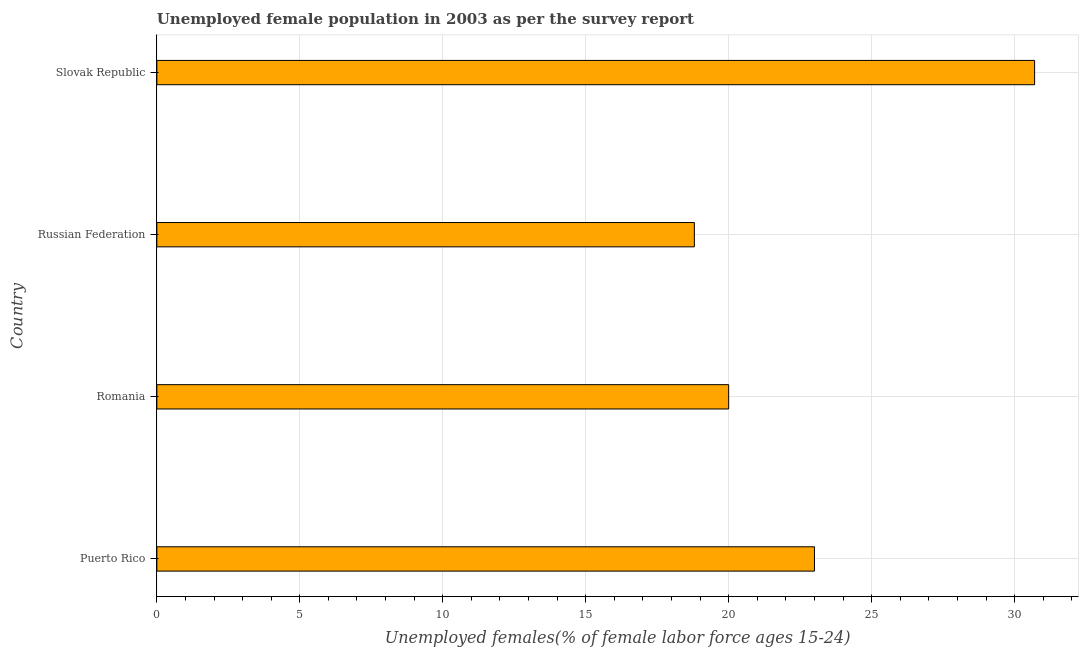Does the graph contain grids?
Your response must be concise. Yes. What is the title of the graph?
Provide a succinct answer. Unemployed female population in 2003 as per the survey report. What is the label or title of the X-axis?
Your answer should be very brief. Unemployed females(% of female labor force ages 15-24). What is the label or title of the Y-axis?
Offer a very short reply. Country. What is the unemployed female youth in Puerto Rico?
Keep it short and to the point. 23. Across all countries, what is the maximum unemployed female youth?
Keep it short and to the point. 30.7. Across all countries, what is the minimum unemployed female youth?
Give a very brief answer. 18.8. In which country was the unemployed female youth maximum?
Offer a terse response. Slovak Republic. In which country was the unemployed female youth minimum?
Ensure brevity in your answer.  Russian Federation. What is the sum of the unemployed female youth?
Provide a succinct answer. 92.5. What is the difference between the unemployed female youth in Romania and Slovak Republic?
Keep it short and to the point. -10.7. What is the average unemployed female youth per country?
Offer a very short reply. 23.12. What is the median unemployed female youth?
Ensure brevity in your answer.  21.5. In how many countries, is the unemployed female youth greater than 23 %?
Make the answer very short. 1. What is the ratio of the unemployed female youth in Puerto Rico to that in Romania?
Provide a short and direct response. 1.15. Is the difference between the unemployed female youth in Puerto Rico and Russian Federation greater than the difference between any two countries?
Your answer should be compact. No. Is the sum of the unemployed female youth in Romania and Slovak Republic greater than the maximum unemployed female youth across all countries?
Provide a succinct answer. Yes. What is the difference between the highest and the lowest unemployed female youth?
Offer a very short reply. 11.9. Are all the bars in the graph horizontal?
Provide a short and direct response. Yes. What is the difference between two consecutive major ticks on the X-axis?
Ensure brevity in your answer.  5. Are the values on the major ticks of X-axis written in scientific E-notation?
Make the answer very short. No. What is the Unemployed females(% of female labor force ages 15-24) of Puerto Rico?
Make the answer very short. 23. What is the Unemployed females(% of female labor force ages 15-24) of Russian Federation?
Make the answer very short. 18.8. What is the Unemployed females(% of female labor force ages 15-24) of Slovak Republic?
Provide a succinct answer. 30.7. What is the difference between the Unemployed females(% of female labor force ages 15-24) in Puerto Rico and Romania?
Make the answer very short. 3. What is the difference between the Unemployed females(% of female labor force ages 15-24) in Puerto Rico and Russian Federation?
Give a very brief answer. 4.2. What is the difference between the Unemployed females(% of female labor force ages 15-24) in Puerto Rico and Slovak Republic?
Your answer should be compact. -7.7. What is the difference between the Unemployed females(% of female labor force ages 15-24) in Romania and Slovak Republic?
Keep it short and to the point. -10.7. What is the difference between the Unemployed females(% of female labor force ages 15-24) in Russian Federation and Slovak Republic?
Your response must be concise. -11.9. What is the ratio of the Unemployed females(% of female labor force ages 15-24) in Puerto Rico to that in Romania?
Provide a short and direct response. 1.15. What is the ratio of the Unemployed females(% of female labor force ages 15-24) in Puerto Rico to that in Russian Federation?
Provide a succinct answer. 1.22. What is the ratio of the Unemployed females(% of female labor force ages 15-24) in Puerto Rico to that in Slovak Republic?
Ensure brevity in your answer.  0.75. What is the ratio of the Unemployed females(% of female labor force ages 15-24) in Romania to that in Russian Federation?
Make the answer very short. 1.06. What is the ratio of the Unemployed females(% of female labor force ages 15-24) in Romania to that in Slovak Republic?
Your answer should be very brief. 0.65. What is the ratio of the Unemployed females(% of female labor force ages 15-24) in Russian Federation to that in Slovak Republic?
Provide a short and direct response. 0.61. 